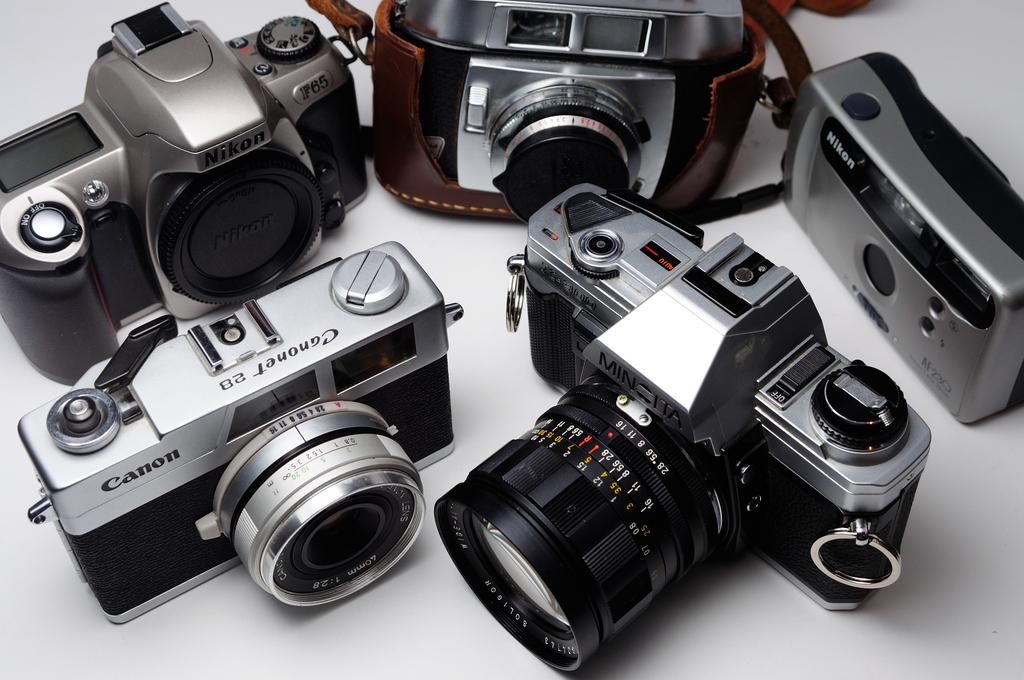What objects are present in the image? There are cameras in the image. What colors can be seen on the cameras? The cameras are silver, black, and brown in color. What is the color of the surface on which the cameras are placed? The cameras are on a white colored surface. What type of flowers can be seen growing around the cameras in the image? There are no flowers present in the image; it only features cameras on a white surface. 